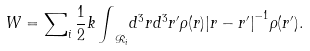<formula> <loc_0><loc_0><loc_500><loc_500>W = { \sum } _ { i } \, \frac { 1 } { 2 } k \, { \int } _ { { \mathcal { R } } _ { i } } { d } ^ { 3 } r { d } ^ { 3 } r ^ { \prime } \rho ( r ) { | r - r ^ { \prime } | } ^ { - 1 } \rho ( r ^ { \prime } ) .</formula> 